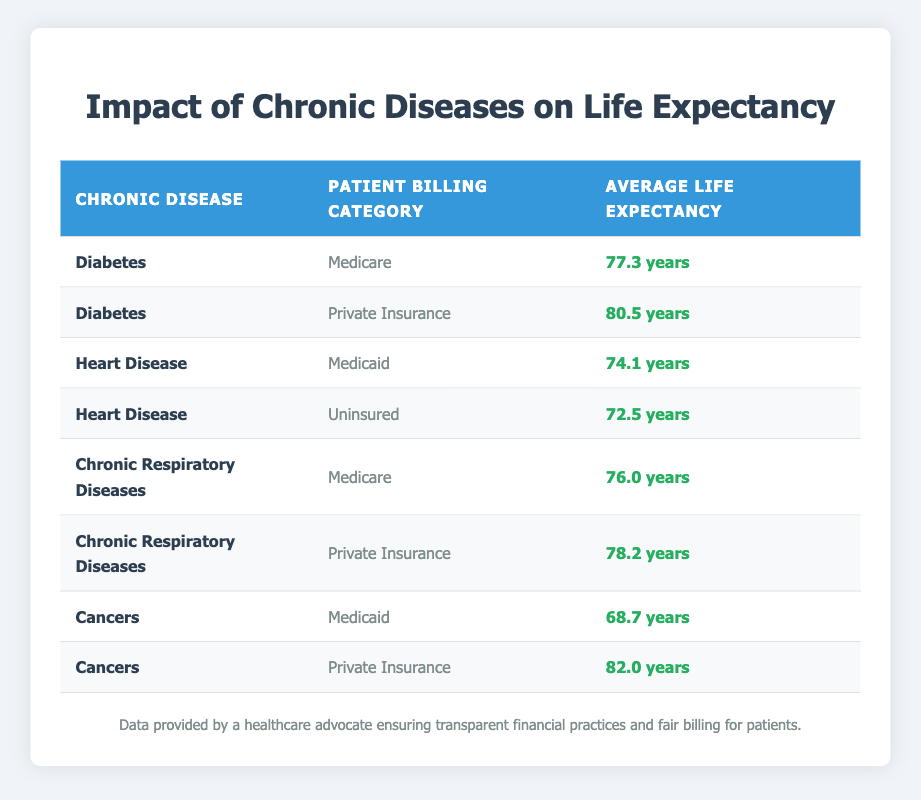What is the average life expectancy for patients with Diabetes covered by Medicare? The table lists the average life expectancy for Diabetes under the Medicare billing category as 77.3 years.
Answer: 77.3 years How does the average life expectancy of patients with Heart Disease compare between Medicaid and Uninsured? According to the table, Heart Disease has an average life expectancy of 74.1 years for Medicaid and 72.5 years for Uninsured. The difference is 74.1 - 72.5 = 1.6 years, meaning Medicaid patients live longer on average.
Answer: Medicaid patients live 1.6 years longer Is the average life expectancy of patients with Chronic Respiratory Diseases higher in Private Insurance compared to Medicare? The average life expectancy for Chronic Respiratory Diseases is 76.0 years for Medicare and 78.2 years for Private Insurance, which shows that Private Insurance patients have a higher life expectancy.
Answer: Yes What is the lowest average life expectancy recorded in the table, and for which chronic disease and billing category? The table shows that the lowest average life expectancy is 68.7 years for Cancers under the Medicaid category.
Answer: 68.7 years for Cancers and Medicaid What is the average life expectancy for patients with Cancers across both billing categories—Medicaid and Private Insurance? The average life expectancy for Cancers is 68.7 years for Medicaid and 82.0 years for Private Insurance. To find the overall average: (68.7 + 82.0) / 2 = 75.35 years.
Answer: 75.35 years 